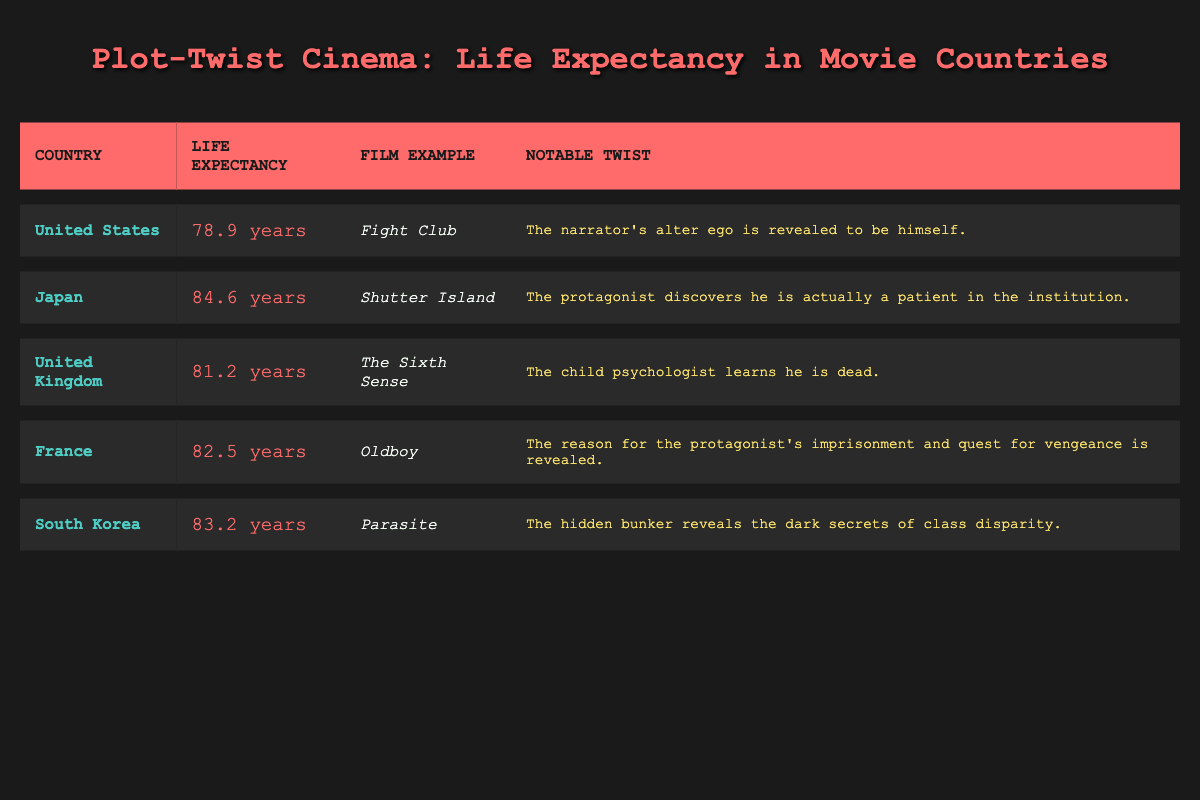What is the life expectancy in Japan? The table shows that Japan has a life expectancy of 84.6 years.
Answer: 84.6 years Which country has the lowest life expectancy in the table? In the table, the United States is listed with the lowest life expectancy at 78.9 years.
Answer: United States What is the difference in life expectancy between Japan and the United Kingdom? Japan has a life expectancy of 84.6 years, while the United Kingdom has 81.2 years. The difference is 84.6 - 81.2 = 3.4 years.
Answer: 3.4 years Is the notable twist in "The Sixth Sense" that the child psychologist is alive? According to the table, the notable twist in "The Sixth Sense" is that the child psychologist learns he is dead. Therefore, the statement is false.
Answer: No What are the life expectancies of South Korea and France combined? South Korea has a life expectancy of 83.2 years and France has 82.5 years. Adding them together gives 83.2 + 82.5 = 165.7 years.
Answer: 165.7 years Which film has the twist involving class disparity, and what is the life expectancy of its country? The film "Parasite" involves the twist about class disparity and its country, South Korea, has a life expectancy of 83.2 years.
Answer: South Korea, 83.2 years What is the average life expectancy of the countries listed in the table? The life expectancies are 78.9 (USA), 84.6 (Japan), 81.2 (UK), 82.5 (France), and 83.2 (South Korea). The total is 410.4 years, so the average is 410.4 / 5 = 82.08 years.
Answer: 82.08 years Which country has a notable twist related to a hidden bunker? The country with a twist involving a hidden bunker is South Korea, as referenced in the film "Parasite."
Answer: South Korea How many countries listed have a life expectancy greater than 82 years? The countries with life expectancy greater than 82 years are Japan (84.6), South Korea (83.2), and France (82.5), totaling three countries.
Answer: 3 